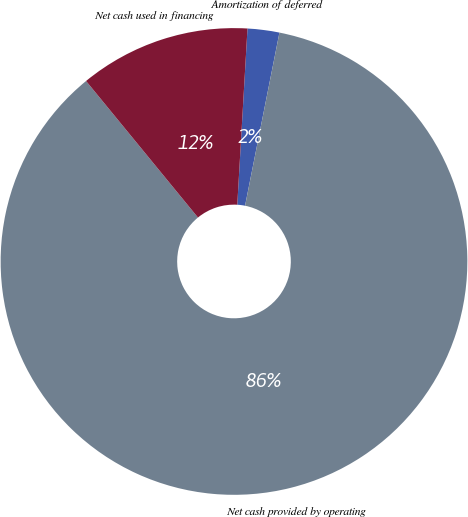Convert chart. <chart><loc_0><loc_0><loc_500><loc_500><pie_chart><fcel>Amortization of deferred<fcel>Net cash provided by operating<fcel>Net cash used in financing<nl><fcel>2.2%<fcel>85.96%<fcel>11.85%<nl></chart> 